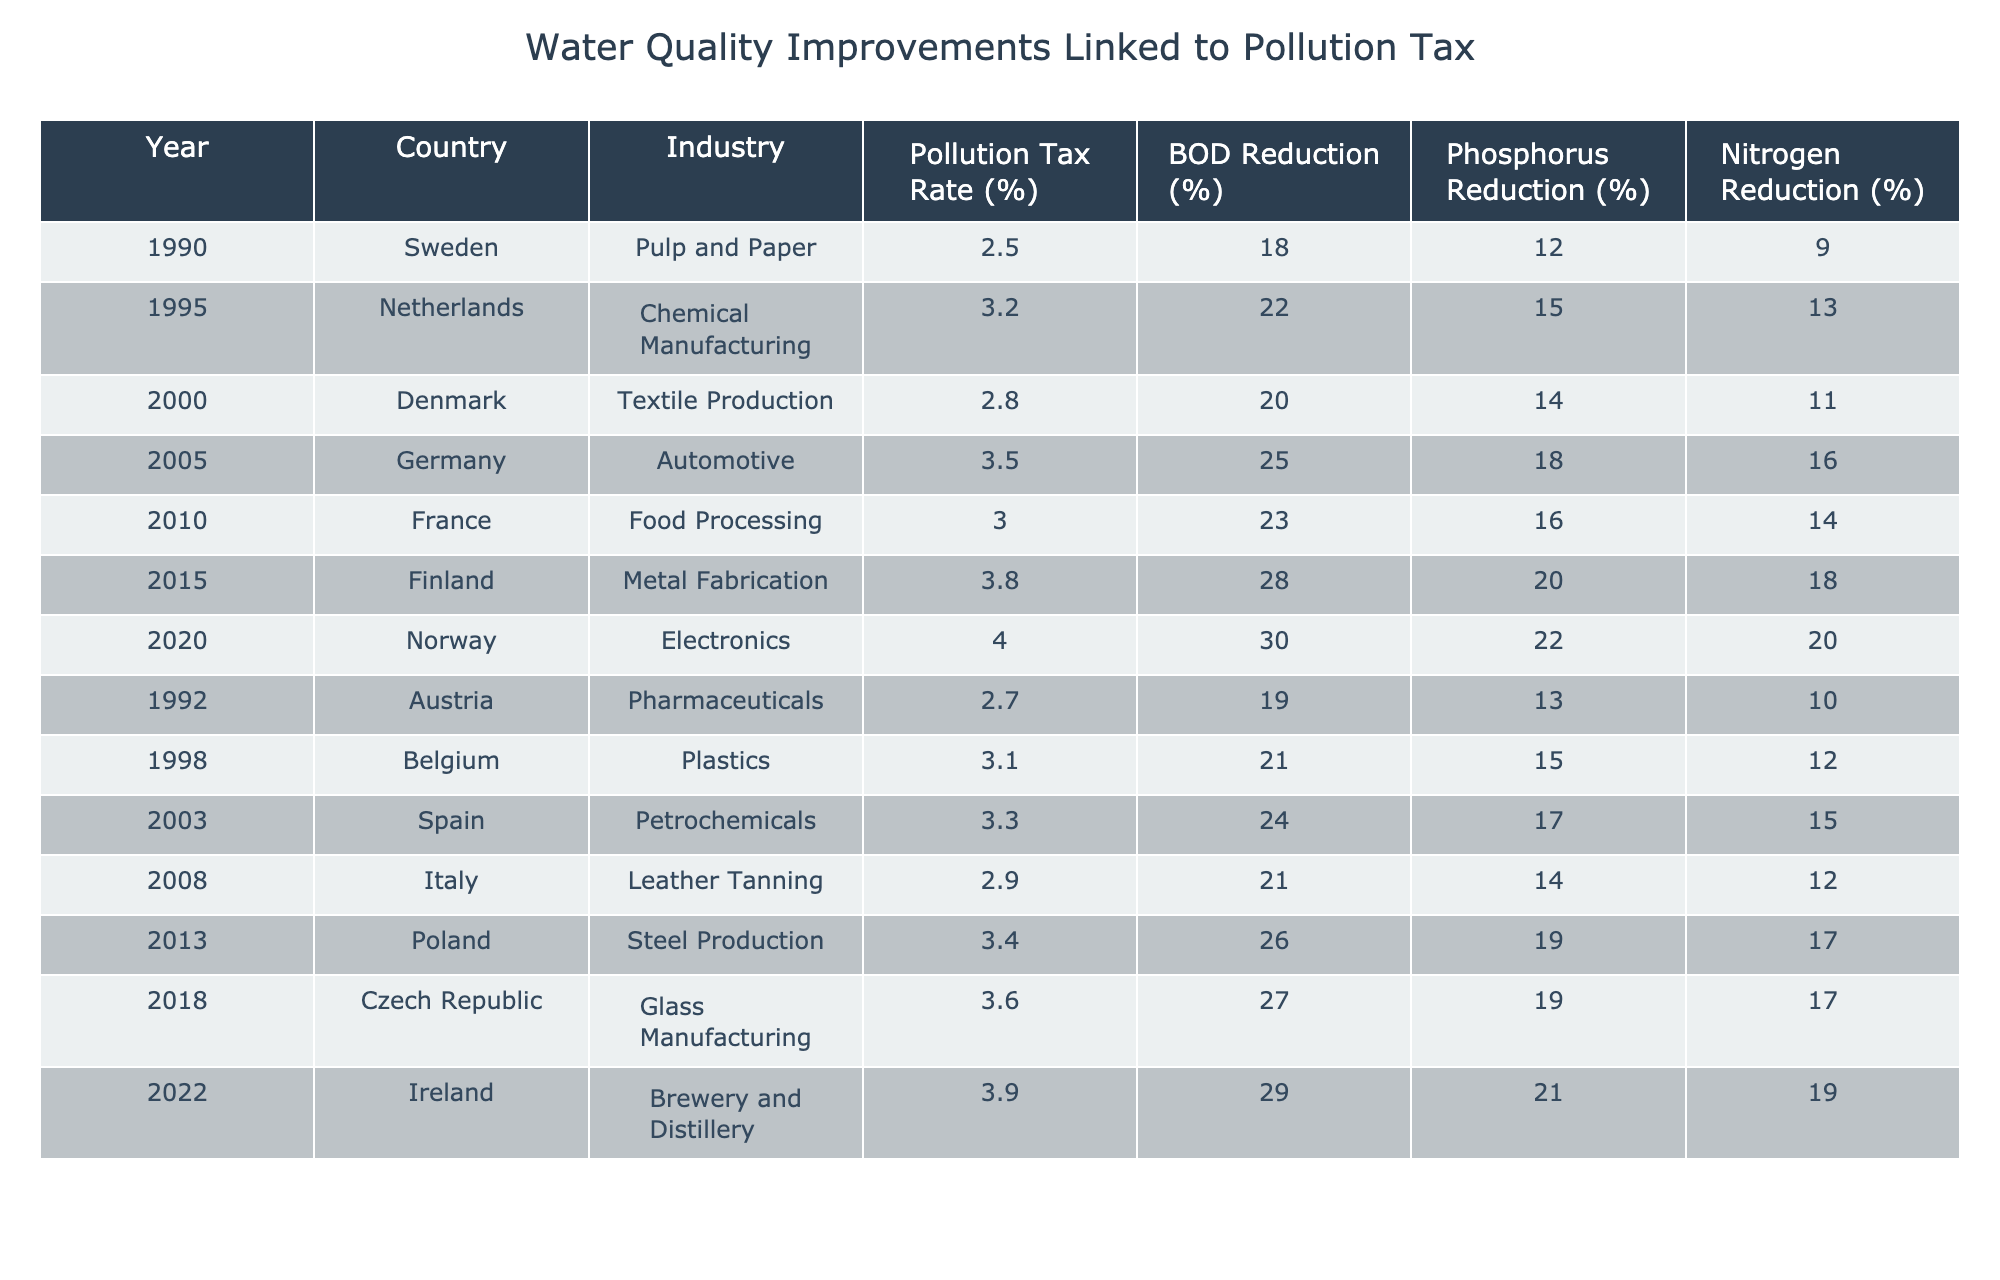What was the highest pollution tax rate in the table? The highest pollution tax rate in the table is found by scanning through the "Pollution Tax Rate (%)" column. The maximum value is 4.0, which corresponds to Norway in 2020.
Answer: 4.0 Which industry had the greatest reduction in BOD? To find the industry with the greatest reduction in BOD, we examine the "BOD Reduction (%)" column for the highest value. The maximum is 30% from the Electronics industry in Norway in 2020.
Answer: Electronics Calculate the average phosphorus reduction across all industries listed. To calculate the average phosphorus reduction, we sum the values in the "Phosphorus Reduction (%)" column: (12 + 15 + 14 + 18 + 16 + 20 + 22 + 13 + 15 + 17 + 14 + 19 + 21) = 235. There are 13 industries, so the average is 235/13 ≈ 18.08%.
Answer: Approximately 18.08% Did Finland have a higher nitrogen reduction than Germany? We compare the nitrogen reduction values from the table. Finland's nitrogen reduction is 18%, and Germany's is 16%. Since 18% is greater than 16%, Finland did have a higher nitrogen reduction.
Answer: Yes Which country implemented a pollution tax rate of 3.5%? By looking at the "Pollution Tax Rate (%)" column for the value of 3.5%, we find that it corresponds to Germany in 2005.
Answer: Germany Is there a correlation between pollution tax rate and BOD reduction? To assess this, we analyze the values from both the "Pollution Tax Rate (%)" and "BOD Reduction (%)" columns. As we observe, higher tax rates generally correspond to higher BOD reductions, suggesting a positive correlation. Thus, we conclude there is indeed a correlation.
Answer: Yes Which industry had the lowest phosphorus reduction? By checking the "Phosphorus Reduction (%)" column, the lowest value is 12%, which is from the Pulp and Paper industry in Sweden in 1990.
Answer: Pulp and Paper Find the year with the minimum nitrogen reduction recorded in the table. We search for the smallest value in the "Nitrogen Reduction (%)" column. The minimum recorded reduction is 9%, which corresponds to Sweden in 1990.
Answer: 1990 If we sum all the BOD reductions, what is the total reduction across all sectors? We add the values from the "BOD Reduction (%)" column: 18 + 22 + 20 + 25 + 23 + 28 + 30 + 19 + 21 + 24 + 26 + 27 + 29 =  31. The total BOD reduction across all sectors is 305%.
Answer: 305% How does the pollution tax rate in Czech Republic compare to that in Finland? The pollution tax rate in the Czech Republic (3.6%) is compared to the rate in Finland (3.8%). Since 3.6% is less than 3.8%, we can conclude that Czech Republic has a lower pollution tax rate.
Answer: Lower 